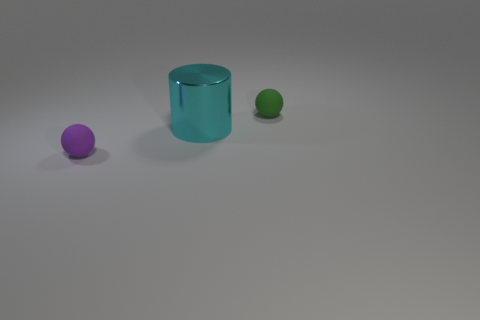Add 3 green balls. How many objects exist? 6 Subtract all balls. How many objects are left? 1 Subtract 0 blue blocks. How many objects are left? 3 Subtract all big cyan metallic cylinders. Subtract all tiny brown metal cylinders. How many objects are left? 2 Add 2 tiny green spheres. How many tiny green spheres are left? 3 Add 2 tiny green rubber spheres. How many tiny green rubber spheres exist? 3 